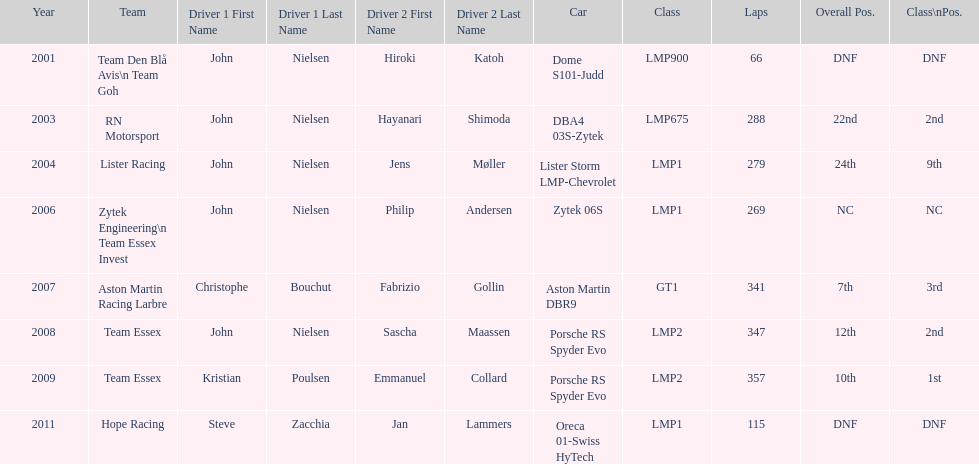Who was casper elgaard's co-driver the most often for the 24 hours of le mans? John Nielsen. 